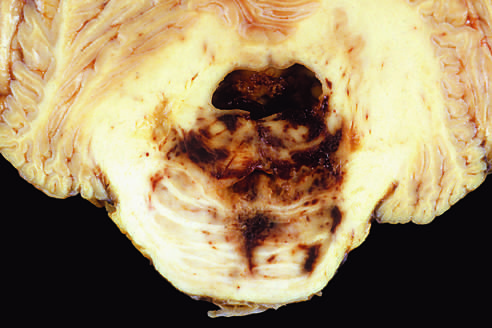s the irreversible injury disruption of the vessels that enter the pons along the midline, leading to hemorrhage?
Answer the question using a single word or phrase. No 